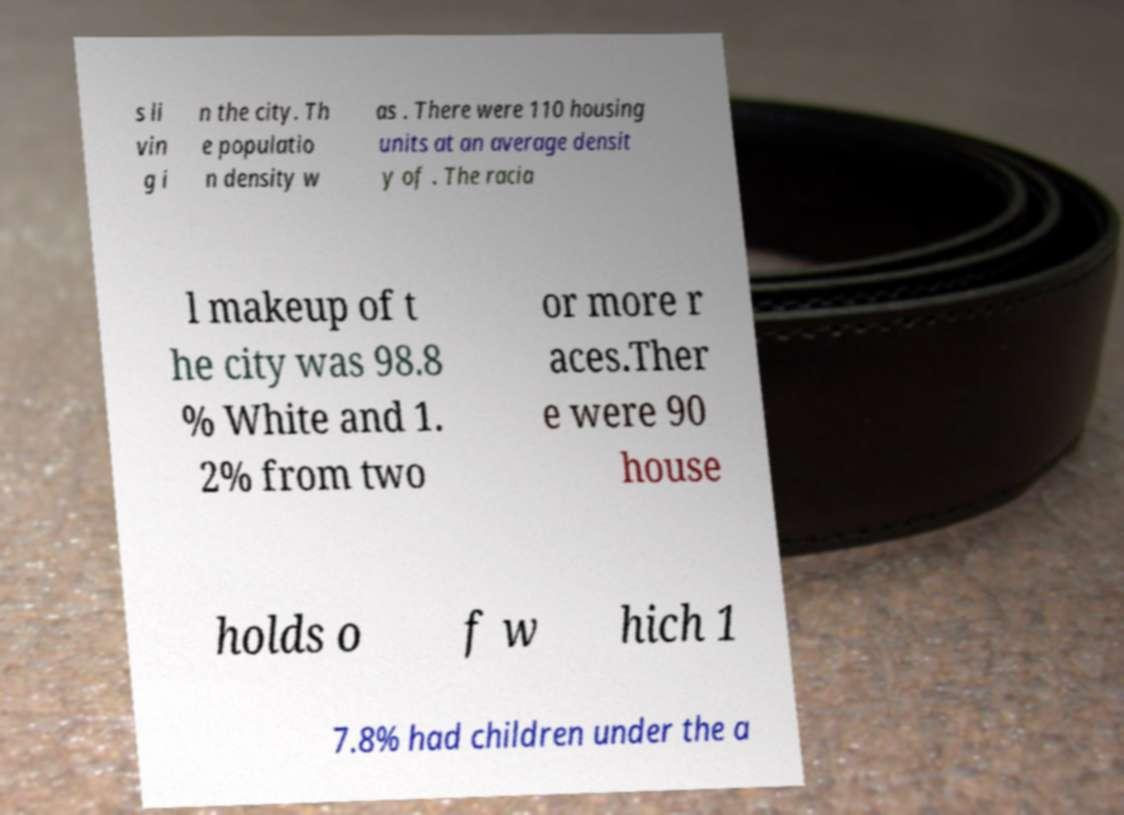What messages or text are displayed in this image? I need them in a readable, typed format. s li vin g i n the city. Th e populatio n density w as . There were 110 housing units at an average densit y of . The racia l makeup of t he city was 98.8 % White and 1. 2% from two or more r aces.Ther e were 90 house holds o f w hich 1 7.8% had children under the a 